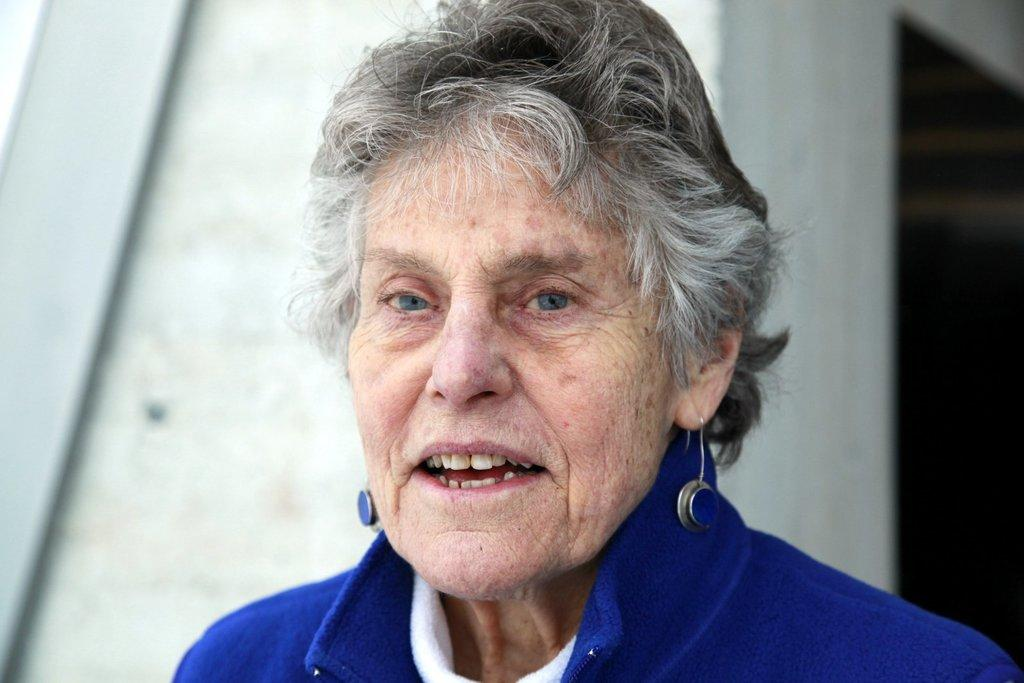Who is the main subject in the image? There is an old woman in the image. What type of scene is depicted in the image? The provided facts do not mention any scene or setting, so it cannot be determined from the image. 